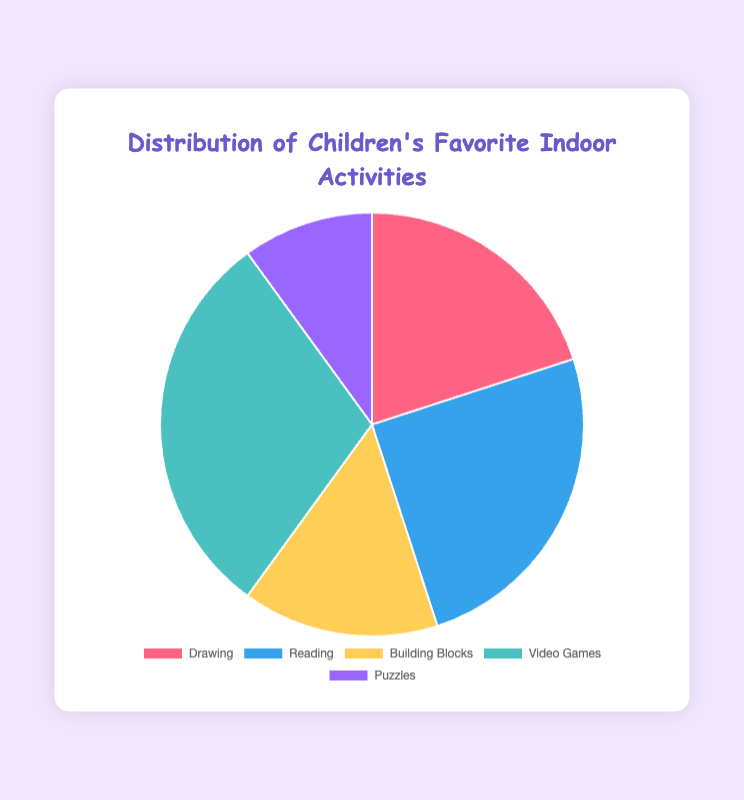What percentage of children prefer Reading over Puzzles? To find the percentage difference, subtract the percentage of children who prefer Puzzles from the percentage who prefer Reading: 25% (Reading) - 10% (Puzzles) = 15%
Answer: 15% What is the combined percentage of children who enjoy Drawing and Building Blocks? Add the percentages of children who like Drawing and Building Blocks: 20% (Drawing) + 15% (Building Blocks) = 35%
Answer: 35% Which activity is the least favored among children? To determine the least favored activity, find the smallest percentage in the chart. Puzzles have the smallest percentage at 10%.
Answer: Puzzles How many more children prefer Video Games compared to Drawing? Subtract the percentage of children who prefer Drawing from those who prefer Video Games: 30% (Video Games) - 20% (Drawing) = 10%
Answer: 10% Which activity has the greatest percentage of children favoring it? To determine the most favored activity, find the largest percentage in the chart. Video Games have the highest percentage at 30%.
Answer: Video Games What is the total percentage of children who prefer activities not involving reading? Sum the percentages of all activities except Reading: 20% (Drawing) + 15% (Building Blocks) + 30% (Video Games) + 10% (Puzzles) = 75%
Answer: 75% If you combine the percentage of children who enjoy Reading and Building Blocks, would it be greater than the percentage of children who prefer Video Games? Sum the percentages of Reading and Building Blocks: 25% (Reading) + 15% (Building Blocks) = 40%. Compare it with the percentage for Video Games: 40% > 30%
Answer: Yes What is the difference between the combined percentage of Drawing and Puzzles and the percentage of Video Games? Add the percentages of Drawing and Puzzles: 20% (Drawing) + 10% (Puzzles) = 30%. Subtract this from the percentage for Video Games: 30% - 30% = 0%
Answer: 0% What color represents the activity with the second-highest percentage of children favoring it? The second-highest percentage is Reading at 25%. Reading is represented by the color blue in the chart.
Answer: Blue 